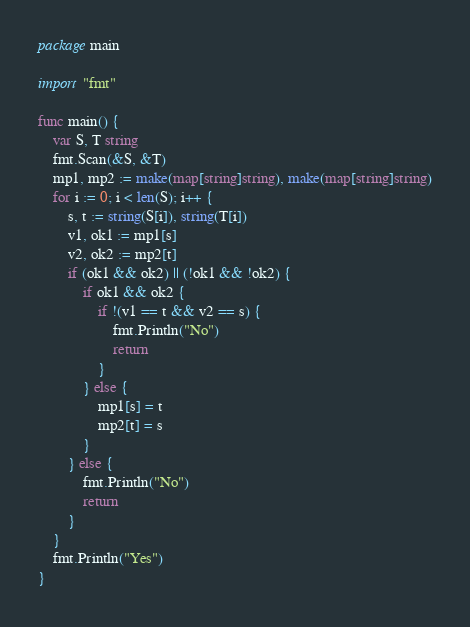Convert code to text. <code><loc_0><loc_0><loc_500><loc_500><_Go_>package main

import "fmt"

func main() {
	var S, T string
	fmt.Scan(&S, &T)
	mp1, mp2 := make(map[string]string), make(map[string]string)
	for i := 0; i < len(S); i++ {
		s, t := string(S[i]), string(T[i])
		v1, ok1 := mp1[s]
		v2, ok2 := mp2[t]
		if (ok1 && ok2) || (!ok1 && !ok2) {
			if ok1 && ok2 {
				if !(v1 == t && v2 == s) {
					fmt.Println("No")
					return
				}
			} else {
				mp1[s] = t
				mp2[t] = s
			}
		} else {
			fmt.Println("No")
			return
		}
	}
	fmt.Println("Yes")
}</code> 